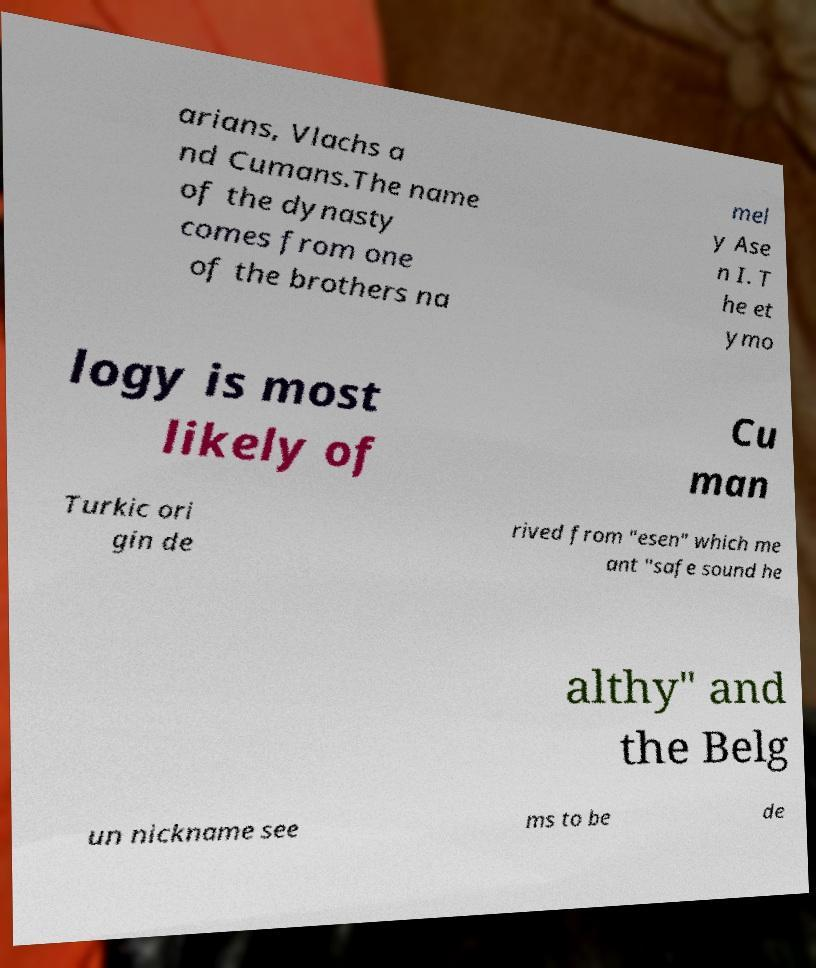For documentation purposes, I need the text within this image transcribed. Could you provide that? arians, Vlachs a nd Cumans.The name of the dynasty comes from one of the brothers na mel y Ase n I. T he et ymo logy is most likely of Cu man Turkic ori gin de rived from "esen" which me ant "safe sound he althy" and the Belg un nickname see ms to be de 